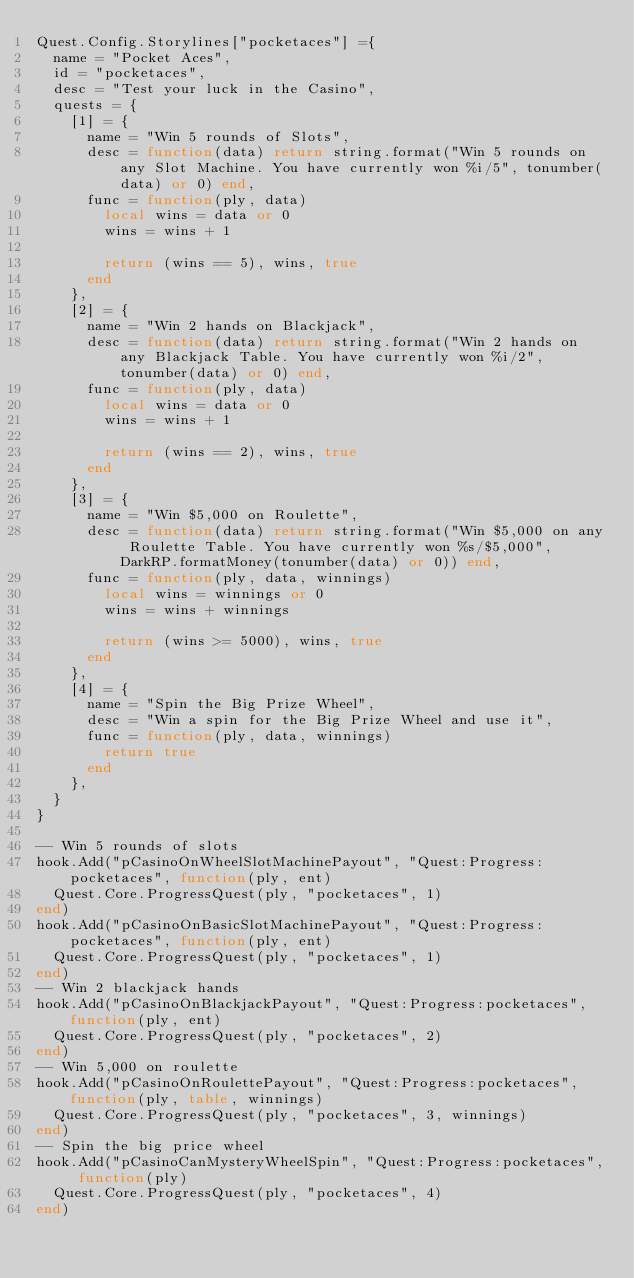<code> <loc_0><loc_0><loc_500><loc_500><_Lua_>Quest.Config.Storylines["pocketaces"] ={
	name = "Pocket Aces",
	id = "pocketaces",
	desc = "Test your luck in the Casino",
	quests = {
		[1] = {
			name = "Win 5 rounds of Slots",
			desc = function(data) return string.format("Win 5 rounds on any Slot Machine. You have currently won %i/5", tonumber(data) or 0) end,
			func = function(ply, data)
				local wins = data or 0
				wins = wins + 1

				return (wins == 5), wins, true
			end
		},
		[2] = {
			name = "Win 2 hands on Blackjack",
			desc = function(data) return string.format("Win 2 hands on any Blackjack Table. You have currently won %i/2", tonumber(data) or 0) end,
			func = function(ply, data)
				local wins = data or 0
				wins = wins + 1

				return (wins == 2), wins, true
			end
		},
		[3] = {
			name = "Win $5,000 on Roulette",
			desc = function(data) return string.format("Win $5,000 on any Roulette Table. You have currently won %s/$5,000", DarkRP.formatMoney(tonumber(data) or 0)) end,
			func = function(ply, data, winnings)
				local wins = winnings or 0
				wins = wins + winnings

				return (wins >= 5000), wins, true
			end
		},
		[4] = {
			name = "Spin the Big Prize Wheel",
			desc = "Win a spin for the Big Prize Wheel and use it",
			func = function(ply, data, winnings)
				return true
			end
		},
	}
}

-- Win 5 rounds of slots
hook.Add("pCasinoOnWheelSlotMachinePayout", "Quest:Progress:pocketaces", function(ply, ent)
	Quest.Core.ProgressQuest(ply, "pocketaces", 1)
end)
hook.Add("pCasinoOnBasicSlotMachinePayout", "Quest:Progress:pocketaces", function(ply, ent)
	Quest.Core.ProgressQuest(ply, "pocketaces", 1)
end)
-- Win 2 blackjack hands
hook.Add("pCasinoOnBlackjackPayout", "Quest:Progress:pocketaces", function(ply, ent)
	Quest.Core.ProgressQuest(ply, "pocketaces", 2)
end)
-- Win 5,000 on roulette
hook.Add("pCasinoOnRoulettePayout", "Quest:Progress:pocketaces", function(ply, table, winnings)
	Quest.Core.ProgressQuest(ply, "pocketaces", 3, winnings)
end)
-- Spin the big price wheel
hook.Add("pCasinoCanMysteryWheelSpin", "Quest:Progress:pocketaces", function(ply)
	Quest.Core.ProgressQuest(ply, "pocketaces", 4)
end)
</code> 